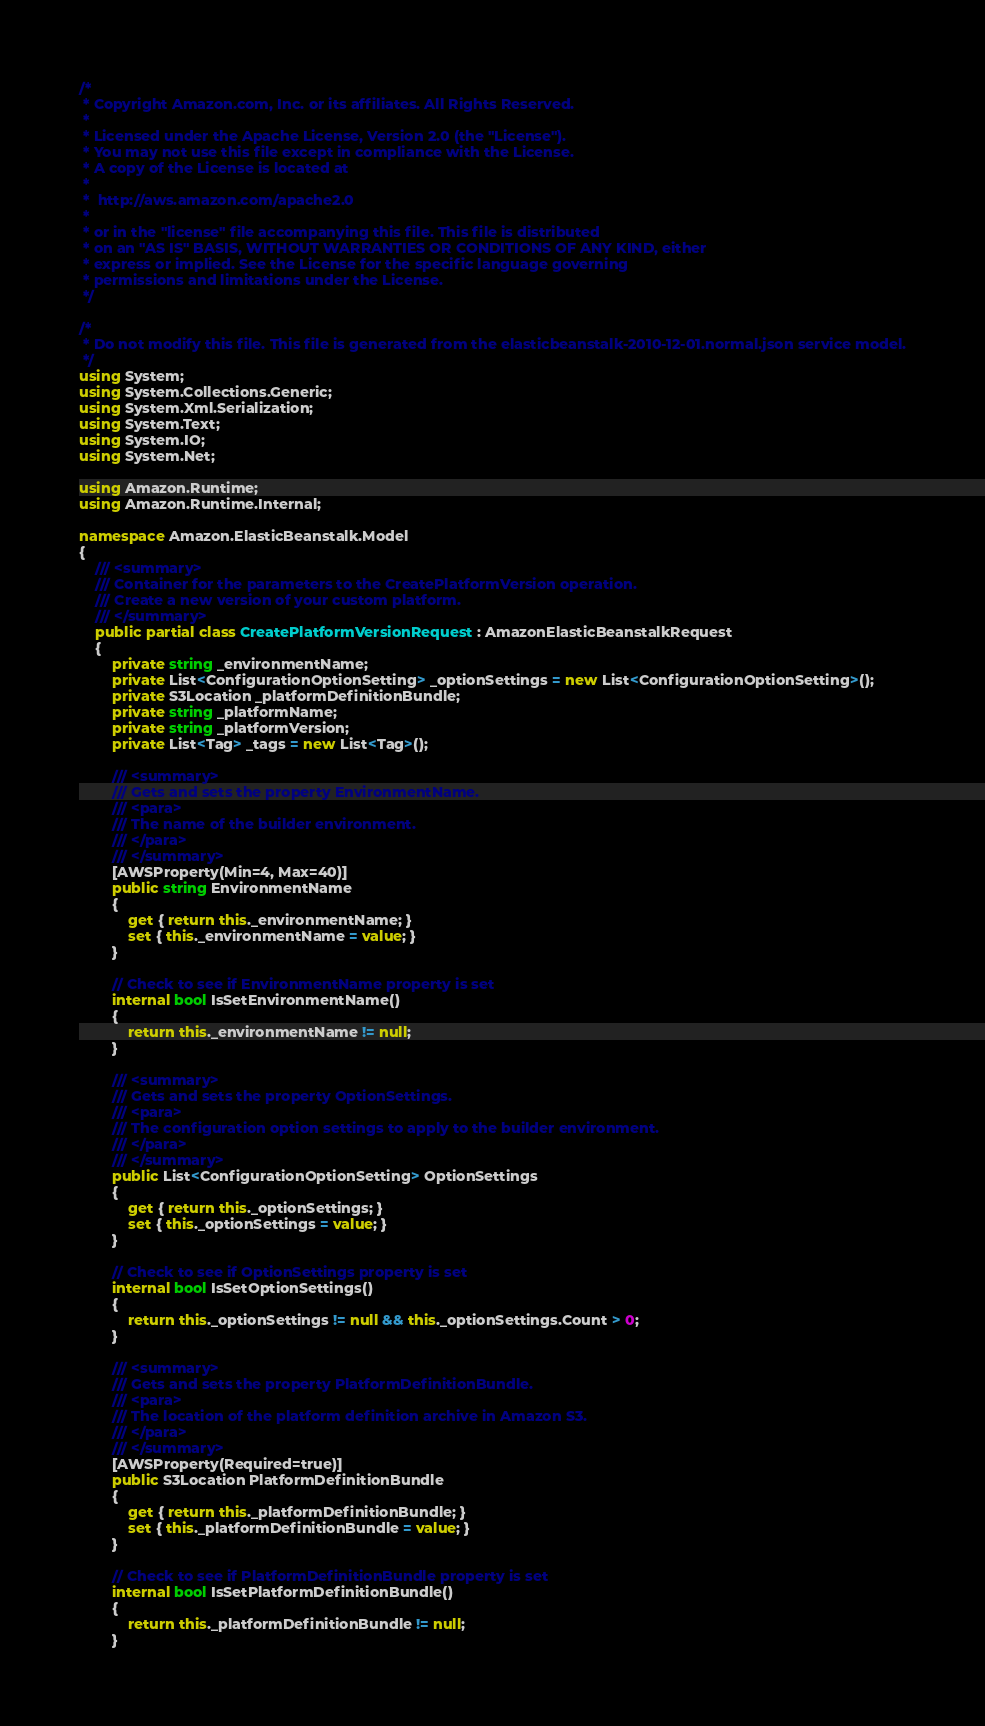Convert code to text. <code><loc_0><loc_0><loc_500><loc_500><_C#_>/*
 * Copyright Amazon.com, Inc. or its affiliates. All Rights Reserved.
 * 
 * Licensed under the Apache License, Version 2.0 (the "License").
 * You may not use this file except in compliance with the License.
 * A copy of the License is located at
 * 
 *  http://aws.amazon.com/apache2.0
 * 
 * or in the "license" file accompanying this file. This file is distributed
 * on an "AS IS" BASIS, WITHOUT WARRANTIES OR CONDITIONS OF ANY KIND, either
 * express or implied. See the License for the specific language governing
 * permissions and limitations under the License.
 */

/*
 * Do not modify this file. This file is generated from the elasticbeanstalk-2010-12-01.normal.json service model.
 */
using System;
using System.Collections.Generic;
using System.Xml.Serialization;
using System.Text;
using System.IO;
using System.Net;

using Amazon.Runtime;
using Amazon.Runtime.Internal;

namespace Amazon.ElasticBeanstalk.Model
{
    /// <summary>
    /// Container for the parameters to the CreatePlatformVersion operation.
    /// Create a new version of your custom platform.
    /// </summary>
    public partial class CreatePlatformVersionRequest : AmazonElasticBeanstalkRequest
    {
        private string _environmentName;
        private List<ConfigurationOptionSetting> _optionSettings = new List<ConfigurationOptionSetting>();
        private S3Location _platformDefinitionBundle;
        private string _platformName;
        private string _platformVersion;
        private List<Tag> _tags = new List<Tag>();

        /// <summary>
        /// Gets and sets the property EnvironmentName. 
        /// <para>
        /// The name of the builder environment.
        /// </para>
        /// </summary>
        [AWSProperty(Min=4, Max=40)]
        public string EnvironmentName
        {
            get { return this._environmentName; }
            set { this._environmentName = value; }
        }

        // Check to see if EnvironmentName property is set
        internal bool IsSetEnvironmentName()
        {
            return this._environmentName != null;
        }

        /// <summary>
        /// Gets and sets the property OptionSettings. 
        /// <para>
        /// The configuration option settings to apply to the builder environment.
        /// </para>
        /// </summary>
        public List<ConfigurationOptionSetting> OptionSettings
        {
            get { return this._optionSettings; }
            set { this._optionSettings = value; }
        }

        // Check to see if OptionSettings property is set
        internal bool IsSetOptionSettings()
        {
            return this._optionSettings != null && this._optionSettings.Count > 0; 
        }

        /// <summary>
        /// Gets and sets the property PlatformDefinitionBundle. 
        /// <para>
        /// The location of the platform definition archive in Amazon S3.
        /// </para>
        /// </summary>
        [AWSProperty(Required=true)]
        public S3Location PlatformDefinitionBundle
        {
            get { return this._platformDefinitionBundle; }
            set { this._platformDefinitionBundle = value; }
        }

        // Check to see if PlatformDefinitionBundle property is set
        internal bool IsSetPlatformDefinitionBundle()
        {
            return this._platformDefinitionBundle != null;
        }
</code> 